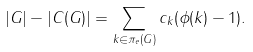<formula> <loc_0><loc_0><loc_500><loc_500>| G | - | C ( G ) | = \sum _ { k \in \pi _ { e } ( G ) } c _ { k } ( \phi ( k ) - 1 ) .</formula> 